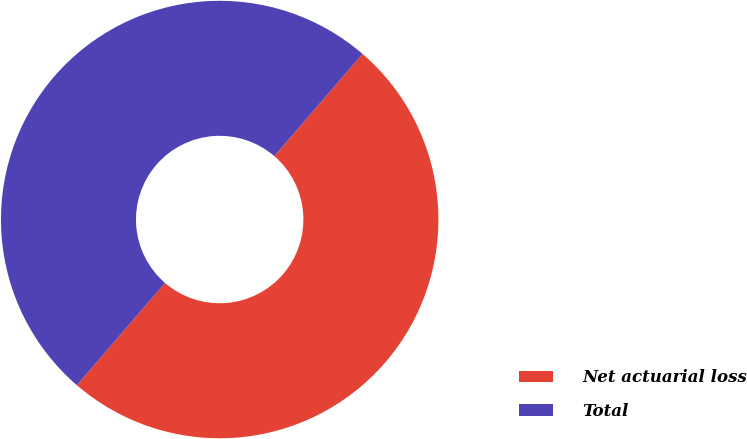Convert chart. <chart><loc_0><loc_0><loc_500><loc_500><pie_chart><fcel>Net actuarial loss<fcel>Total<nl><fcel>50.0%<fcel>50.0%<nl></chart> 